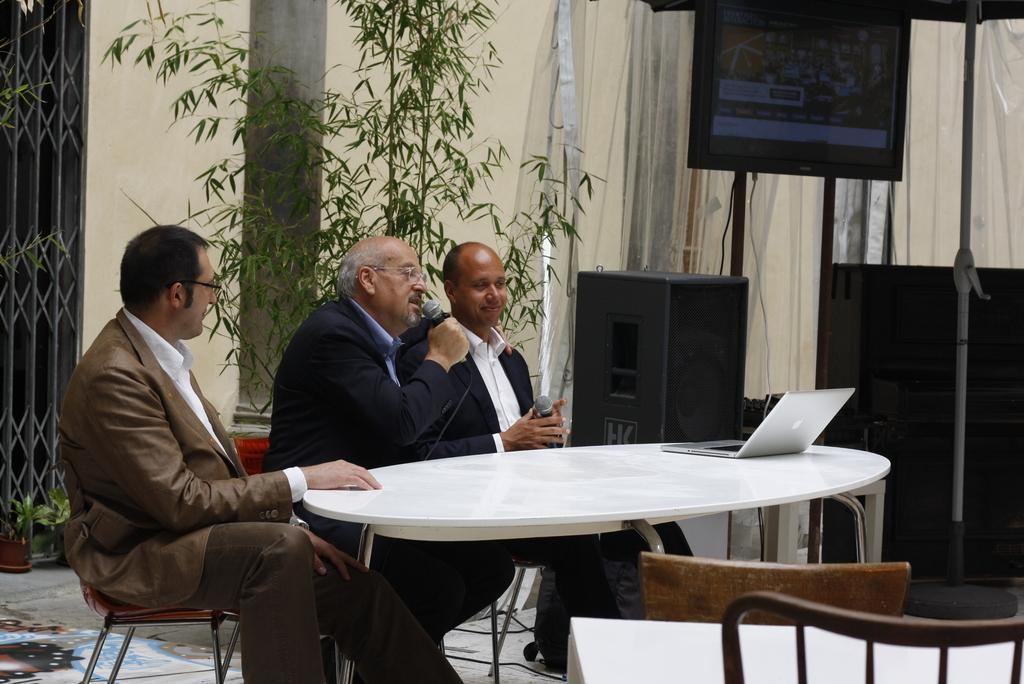How many people are in the image? There are three men in the image. What are the men doing in the image? The men are sitting on chairs and holding microphones in their hands. What type of substance can be seen on the floor near the men in the image? There is no substance visible on the floor near the men in the image; the image only shows the men sitting on chairs and holding microphones. 